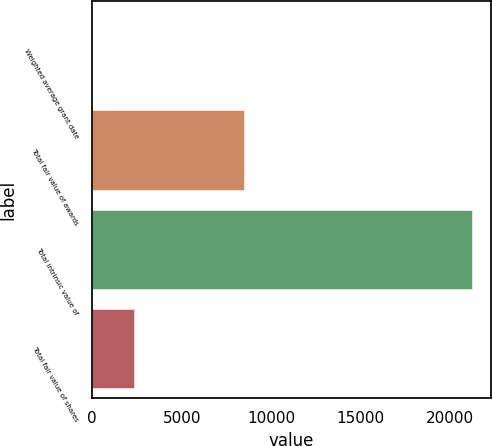Convert chart. <chart><loc_0><loc_0><loc_500><loc_500><bar_chart><fcel>Weighted average grant date<fcel>Total fair value of awards<fcel>Total intrinsic value of<fcel>Total fair value of shares<nl><fcel>11.61<fcel>8492<fcel>21234<fcel>2359<nl></chart> 